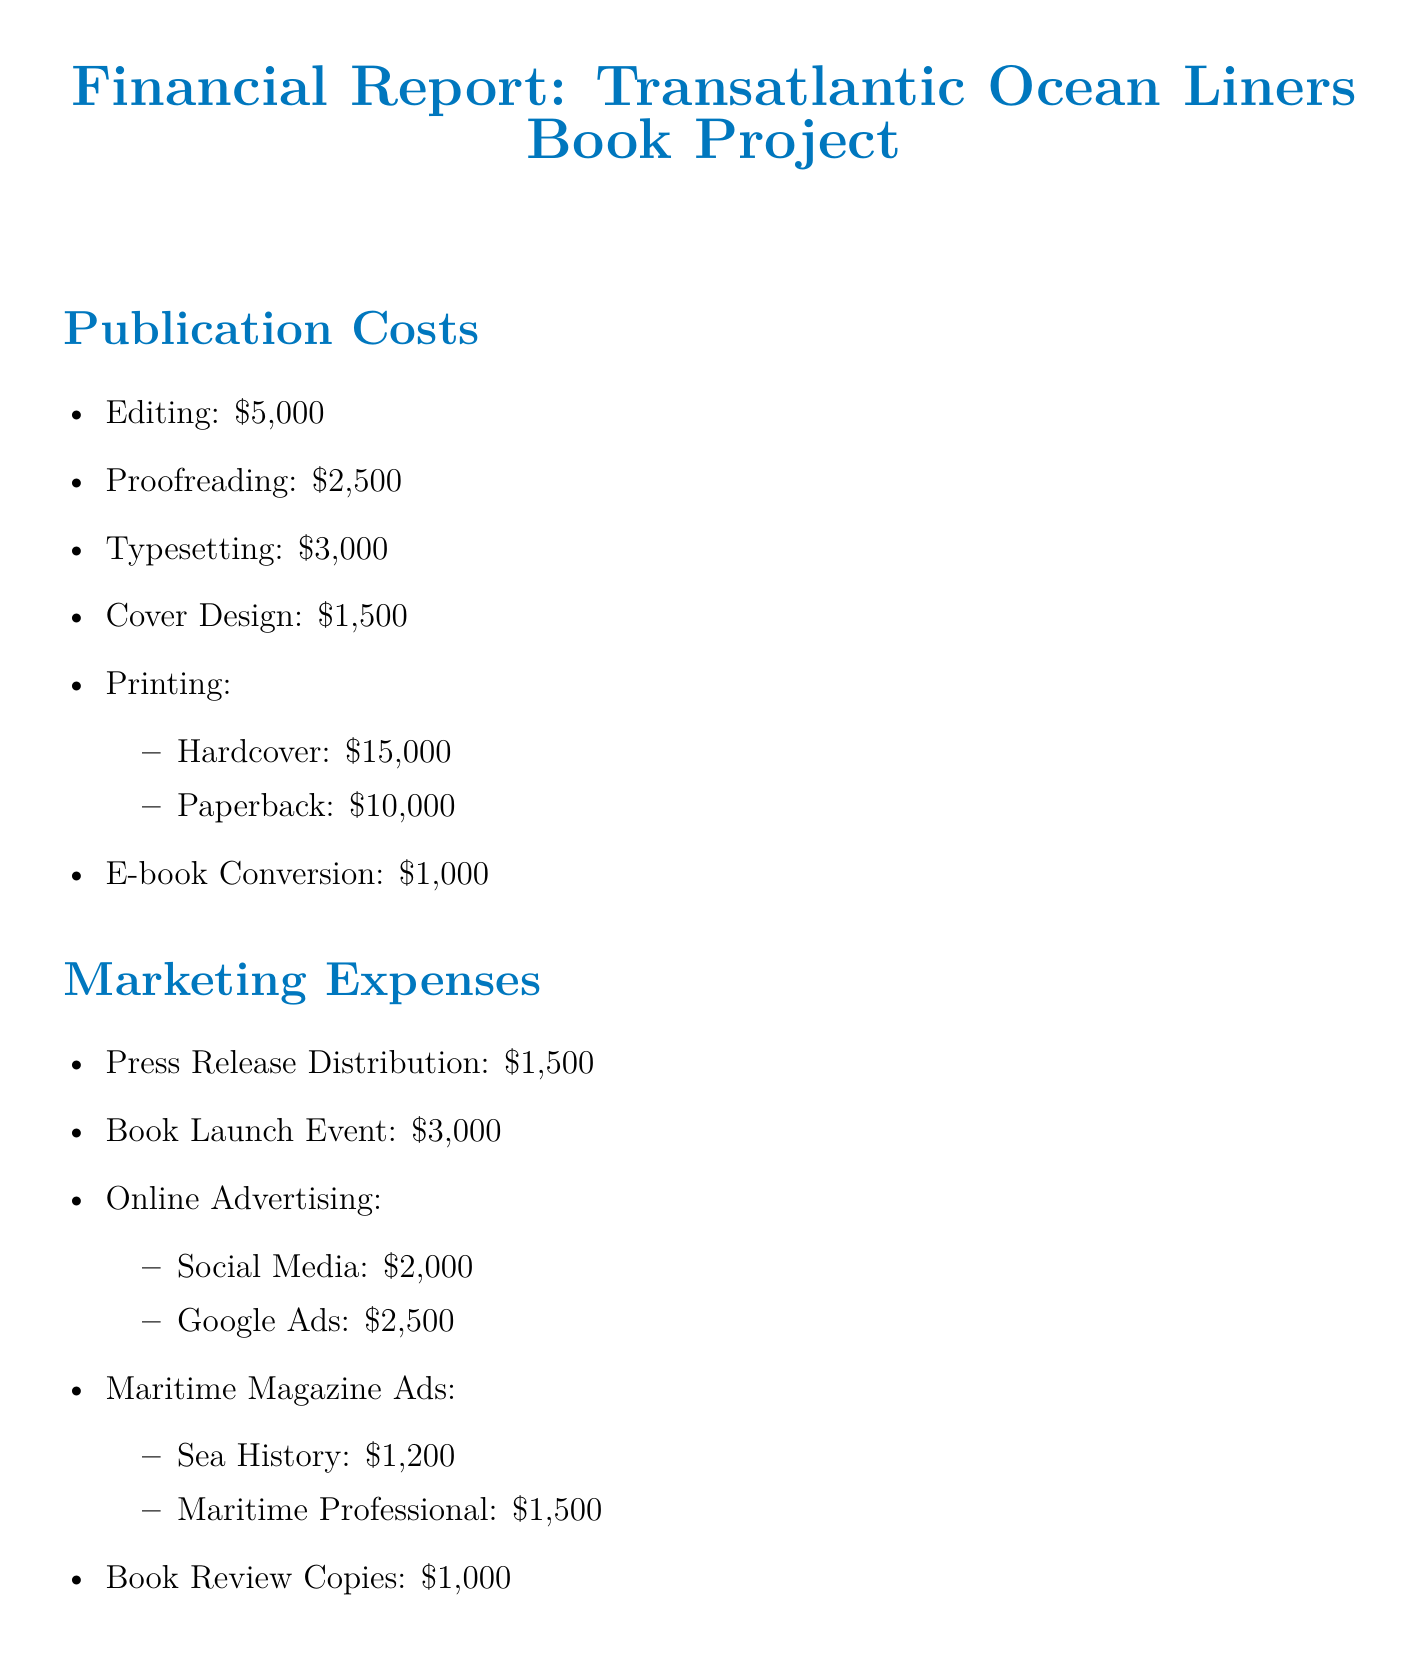What is the total publication cost? The total publication cost is the sum of all individual publication costs listed in the document: 5000 + 2500 + 3000 + 1500 + 15000 + 10000 + 1000 = 50000.
Answer: 50000 How much is allocated for online advertising? The online advertising cost is specifically broken down into social media and Google Ads, totaling 2000 + 2500 = 4500.
Answer: 4500 What are the total projected sales units for hardcover? The document specifies 5000 units for hardcover sales.
Answer: 5000 What is the royalty rate percentage? The document explicitly states that the royalty rate is 15%.
Answer: 15% What is the budget for the book launch event? The marketing expenses section indicates that the budget for the book launch event is 3000.
Answer: 3000 What is the ISBN registration cost? The cost for ISBN registration is clearly marked in the professional services section as 125.
Answer: 125 What is the total revenue from paperback sales? The document indicates that the total revenue from paperback sales is calculated as 7500 units multiplied by the price of 19.99 per unit, which results in 149925.
Answer: 149925 What is the advance from the publisher? The document states that the advance from the publisher is 10000.
Answer: 10000 What is the cost for shipping and handling? The distribution costs section specifies that shipping and handling costs are 3000.
Answer: 3000 